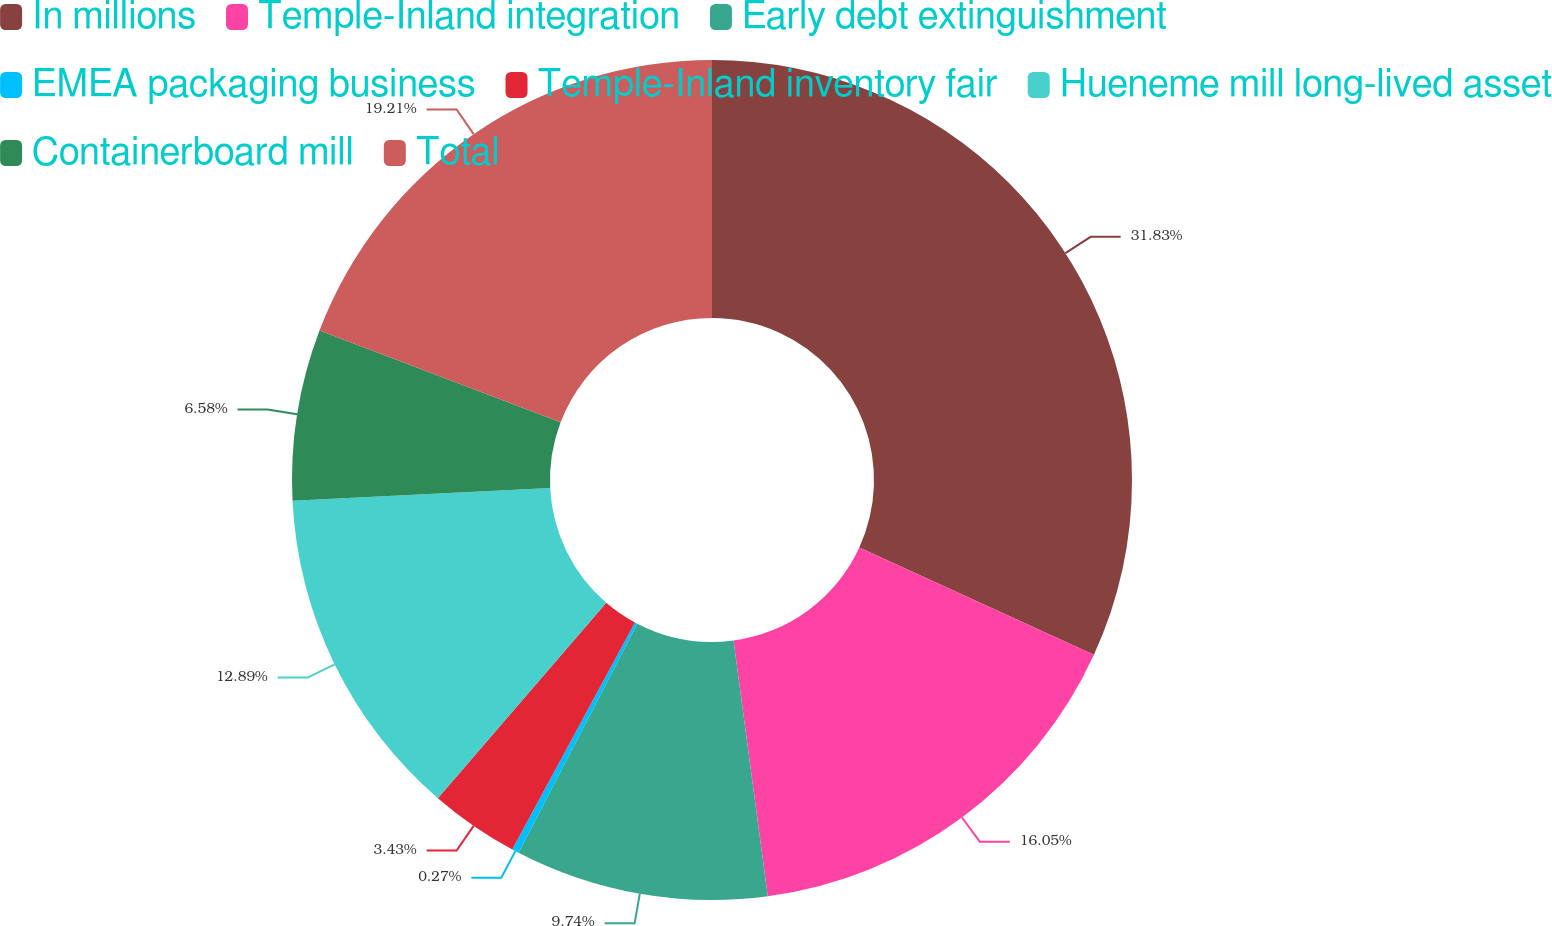Convert chart to OTSL. <chart><loc_0><loc_0><loc_500><loc_500><pie_chart><fcel>In millions<fcel>Temple-Inland integration<fcel>Early debt extinguishment<fcel>EMEA packaging business<fcel>Temple-Inland inventory fair<fcel>Hueneme mill long-lived asset<fcel>Containerboard mill<fcel>Total<nl><fcel>31.83%<fcel>16.05%<fcel>9.74%<fcel>0.27%<fcel>3.43%<fcel>12.89%<fcel>6.58%<fcel>19.21%<nl></chart> 